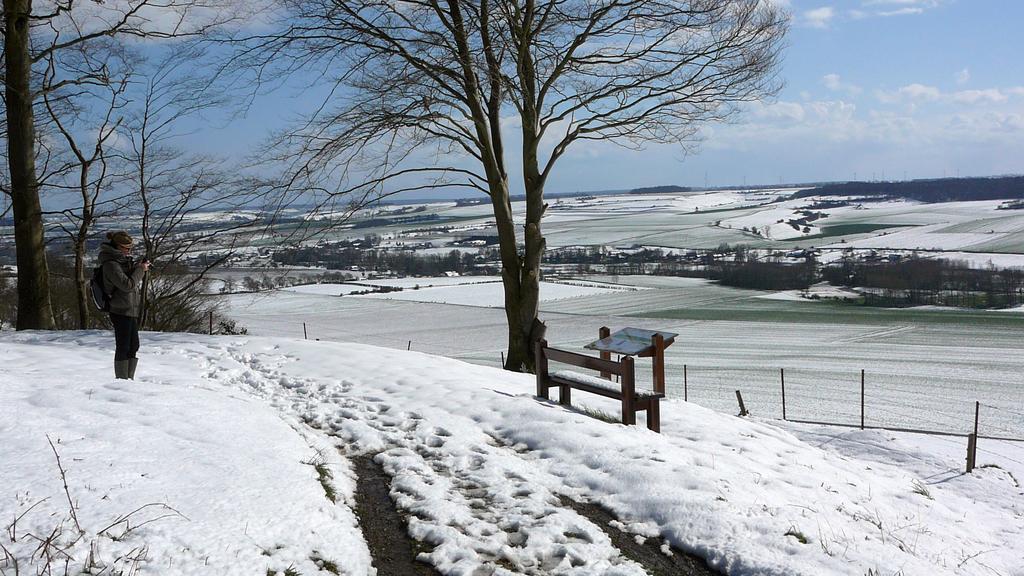Please provide a concise description of this image. In this picture we can see a person standing on the snow. On the right side of the person, there are poles, a bench and a board. Behind the person, there are trees and the sky. 